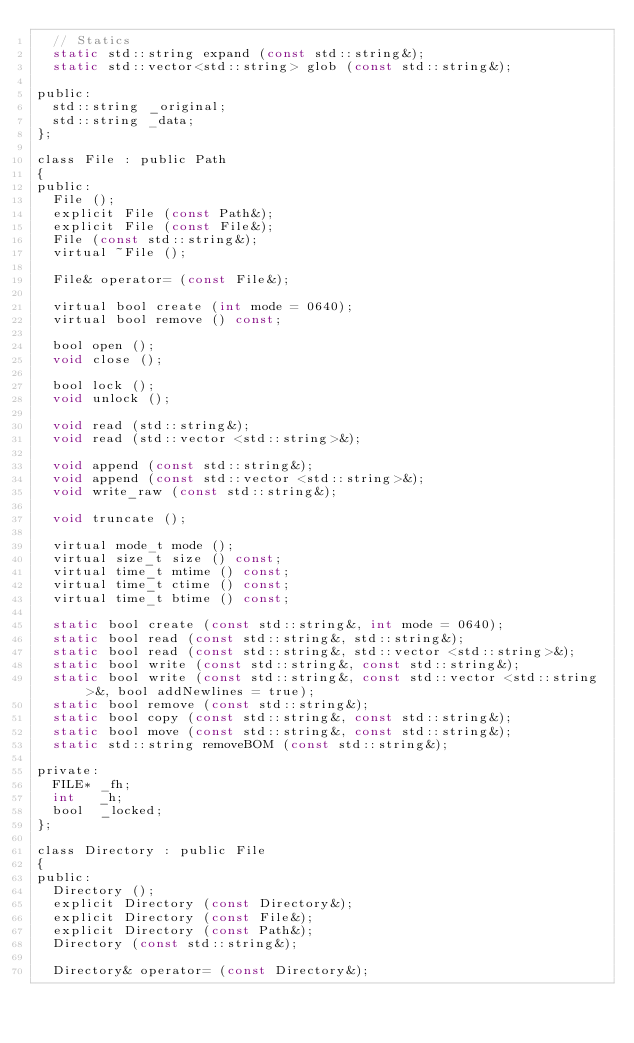Convert code to text. <code><loc_0><loc_0><loc_500><loc_500><_C_>  // Statics
  static std::string expand (const std::string&);
  static std::vector<std::string> glob (const std::string&);

public:
  std::string _original;
  std::string _data;
};

class File : public Path
{
public:
  File ();
  explicit File (const Path&);
  explicit File (const File&);
  File (const std::string&);
  virtual ~File ();

  File& operator= (const File&);

  virtual bool create (int mode = 0640);
  virtual bool remove () const;

  bool open ();
  void close ();

  bool lock ();
  void unlock ();

  void read (std::string&);
  void read (std::vector <std::string>&);

  void append (const std::string&);
  void append (const std::vector <std::string>&);
  void write_raw (const std::string&);

  void truncate ();

  virtual mode_t mode ();
  virtual size_t size () const;
  virtual time_t mtime () const;
  virtual time_t ctime () const;
  virtual time_t btime () const;

  static bool create (const std::string&, int mode = 0640);
  static bool read (const std::string&, std::string&);
  static bool read (const std::string&, std::vector <std::string>&);
  static bool write (const std::string&, const std::string&);
  static bool write (const std::string&, const std::vector <std::string>&, bool addNewlines = true);
  static bool remove (const std::string&);
  static bool copy (const std::string&, const std::string&);
  static bool move (const std::string&, const std::string&);
  static std::string removeBOM (const std::string&);

private:
  FILE* _fh;
  int   _h;
  bool  _locked;
};

class Directory : public File
{
public:
  Directory ();
  explicit Directory (const Directory&);
  explicit Directory (const File&);
  explicit Directory (const Path&);
  Directory (const std::string&);

  Directory& operator= (const Directory&);
</code> 